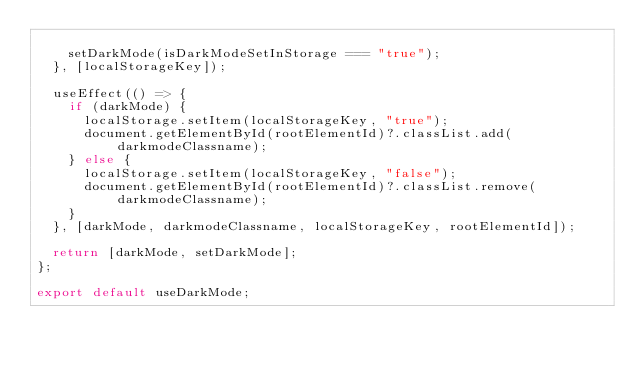Convert code to text. <code><loc_0><loc_0><loc_500><loc_500><_TypeScript_>
    setDarkMode(isDarkModeSetInStorage === "true");
  }, [localStorageKey]);

  useEffect(() => {
    if (darkMode) {
      localStorage.setItem(localStorageKey, "true");
      document.getElementById(rootElementId)?.classList.add(darkmodeClassname);
    } else {
      localStorage.setItem(localStorageKey, "false");
      document.getElementById(rootElementId)?.classList.remove(darkmodeClassname);
    }
  }, [darkMode, darkmodeClassname, localStorageKey, rootElementId]);

  return [darkMode, setDarkMode];
};

export default useDarkMode;
</code> 